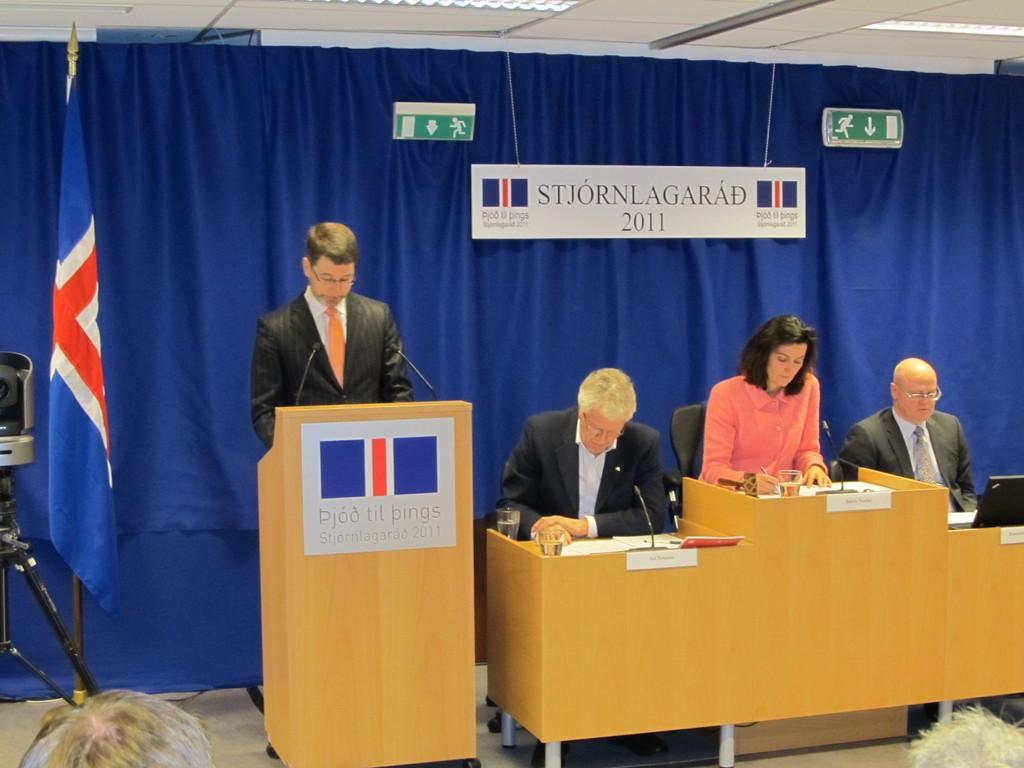<image>
Present a compact description of the photo's key features. A person is standing at a podium next to three other people at Stjornlagarad 2011. 